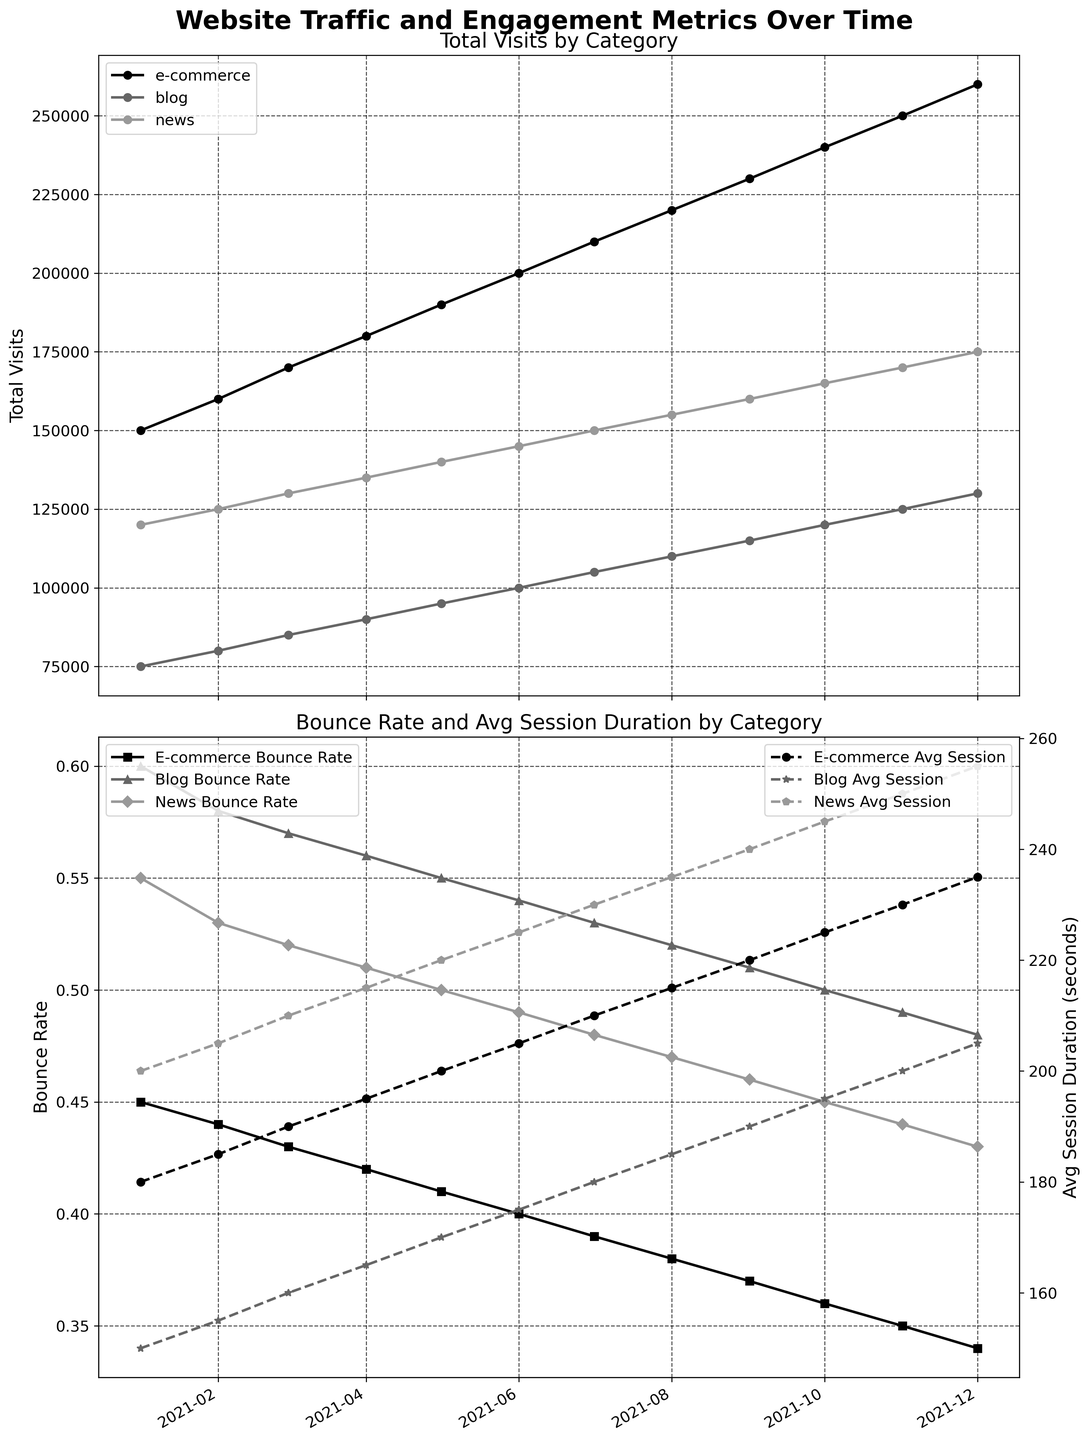What's the title of the first plot? The first plot shows the "Total Visits by Category." This is determined by looking at the title directly above the first subplot.
Answer: Total Visits by Category Which category had the highest total visits in December 2021? By examining the last data point in each series for December 2021, it's clear that the e-commerce category had the highest total visits as its line is the highest.
Answer: E-commerce How did the bounce rate for blogs change from January to December 2021? To determine this, look at the points corresponding to blogs on the second plot from January and December. The bounce rate decreased from 0.60 to 0.48.
Answer: Decreased What was the average session duration for news websites in July 2021? Check the data point for news websites in July 2021 on the right y-axis of the second plot. The average session duration was 230 seconds.
Answer: 230 seconds Which month had the highest total visits for e-commerce websites? Observe the plot of total visits for the e-commerce category and identify the peak value. The highest total visits were in December 2021.
Answer: December 2021 Between e-commerce and news websites, which had a lower bounce rate in August 2021? Compare the bounce rate lines for e-commerce and news in August 2021. Notice that the line for e-commerce is below that for news websites, indicating a lower bounce rate.
Answer: E-commerce What is the difference in average session duration between blogs and news websites in March 2021? Identify the average session duration data points for both blogs and news websites in March 2021 from the second plot. Blogs had 160 seconds, and news had 210 seconds. The difference is 210 - 160 = 50 seconds.
Answer: 50 seconds How does the trend in page views for blogs compare to the trend in total visits for e-commerce over the year? The plot doesn't directly show page views, but observing that blog traffic steadily increased suggests an increasing trend similar to the total visits for e-commerce, though at a smaller scale. Both have upward trends over the year.
Answer: Both have upward trends 